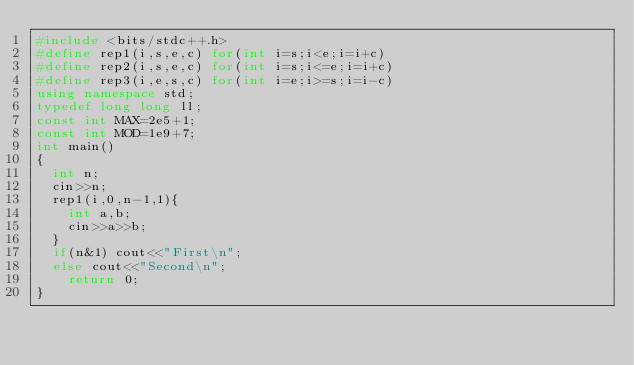Convert code to text. <code><loc_0><loc_0><loc_500><loc_500><_C++_>#include <bits/stdc++.h>
#define rep1(i,s,e,c) for(int i=s;i<e;i=i+c)
#define rep2(i,s,e,c) for(int i=s;i<=e;i=i+c)
#define rep3(i,e,s,c) for(int i=e;i>=s;i=i-c)
using namespace std;
typedef long long ll;
const int MAX=2e5+1;
const int MOD=1e9+7;
int main()
{
	int n;
	cin>>n;
	rep1(i,0,n-1,1){
		int a,b;
		cin>>a>>b;
	}
	if(n&1) cout<<"First\n";
	else cout<<"Second\n";
    return 0;
}    
         </code> 